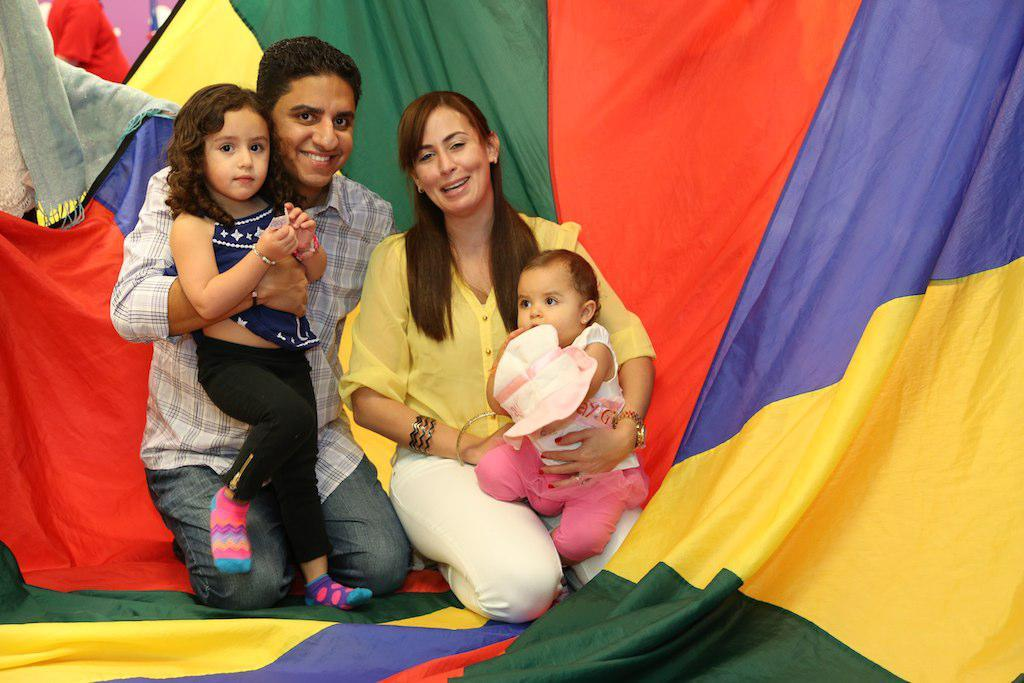Who are the two people in the image? There is a man and a woman in the image. What are the man and woman doing in the image? They are both sitting on their knees and holding babies. What can be seen in the background of the image? There is a curtain in the background of the image. Are there any other people visible in the image? Yes, there is at least one person in the background of the image. What is the story behind the increase in house prices in the image? There is no mention of house prices or any story in the image; it features a man, a woman, and babies. 